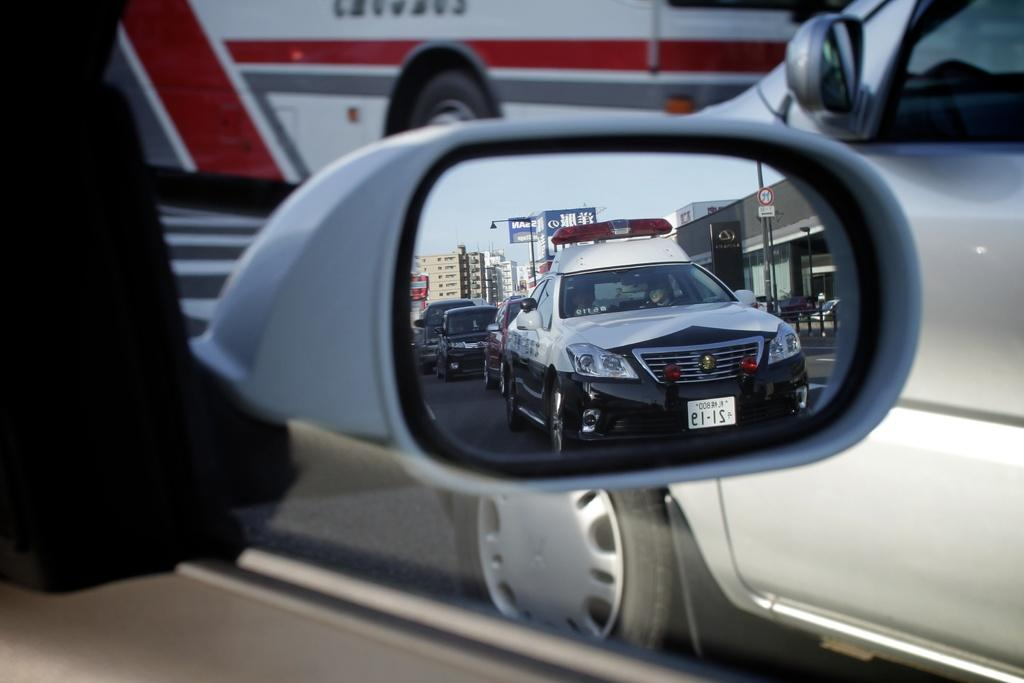What part of a car is shown in the image? There is a side mirror of a car in the image. What can be seen in the side mirror? The side mirror reflects other cars. What type of vehicle is visible in the image? There is a bus in the image, and there is also a car on the right side of the image. What type of vase is placed on the boundary in the image? There is no vase or boundary present in the image. How many feet are visible in the image? There are no feet visible in the image. 